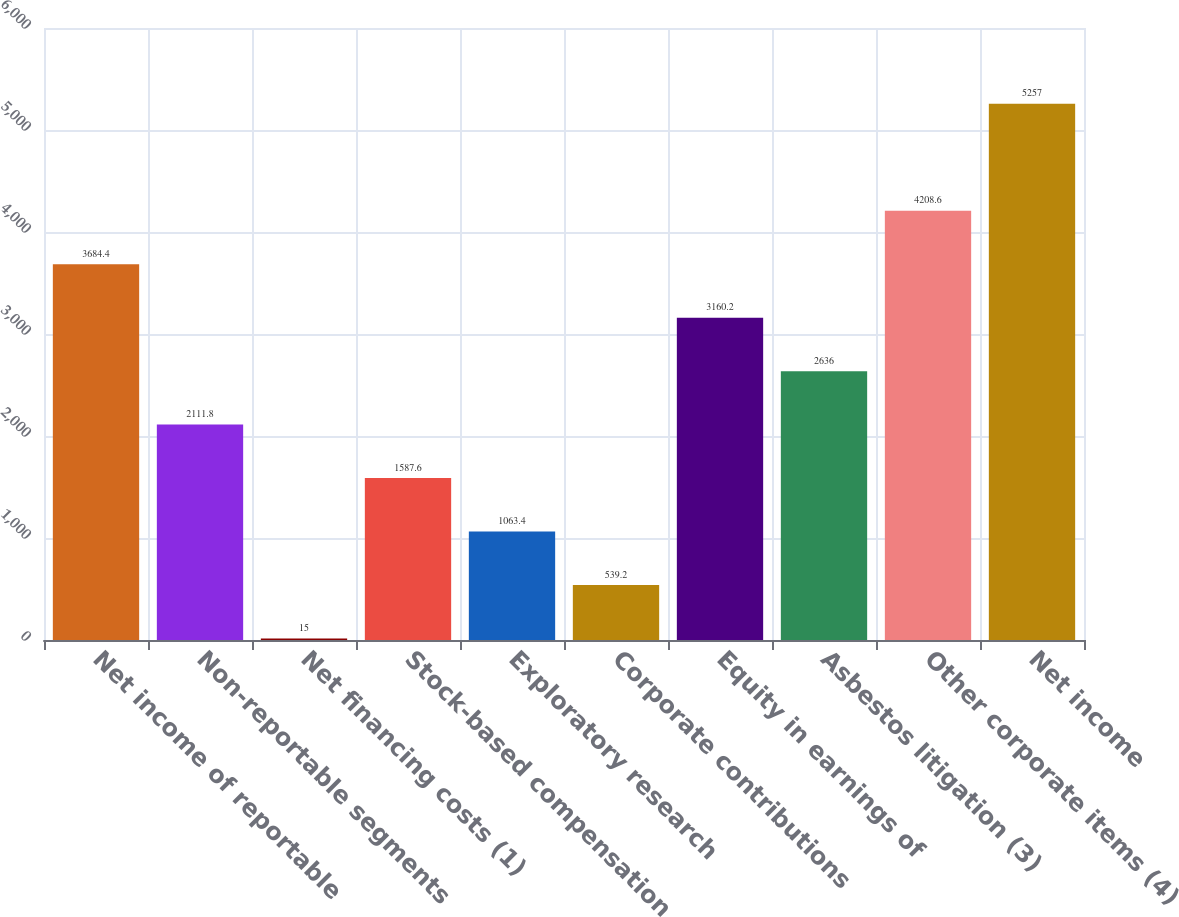Convert chart to OTSL. <chart><loc_0><loc_0><loc_500><loc_500><bar_chart><fcel>Net income of reportable<fcel>Non-reportable segments<fcel>Net financing costs (1)<fcel>Stock-based compensation<fcel>Exploratory research<fcel>Corporate contributions<fcel>Equity in earnings of<fcel>Asbestos litigation (3)<fcel>Other corporate items (4)<fcel>Net income<nl><fcel>3684.4<fcel>2111.8<fcel>15<fcel>1587.6<fcel>1063.4<fcel>539.2<fcel>3160.2<fcel>2636<fcel>4208.6<fcel>5257<nl></chart> 